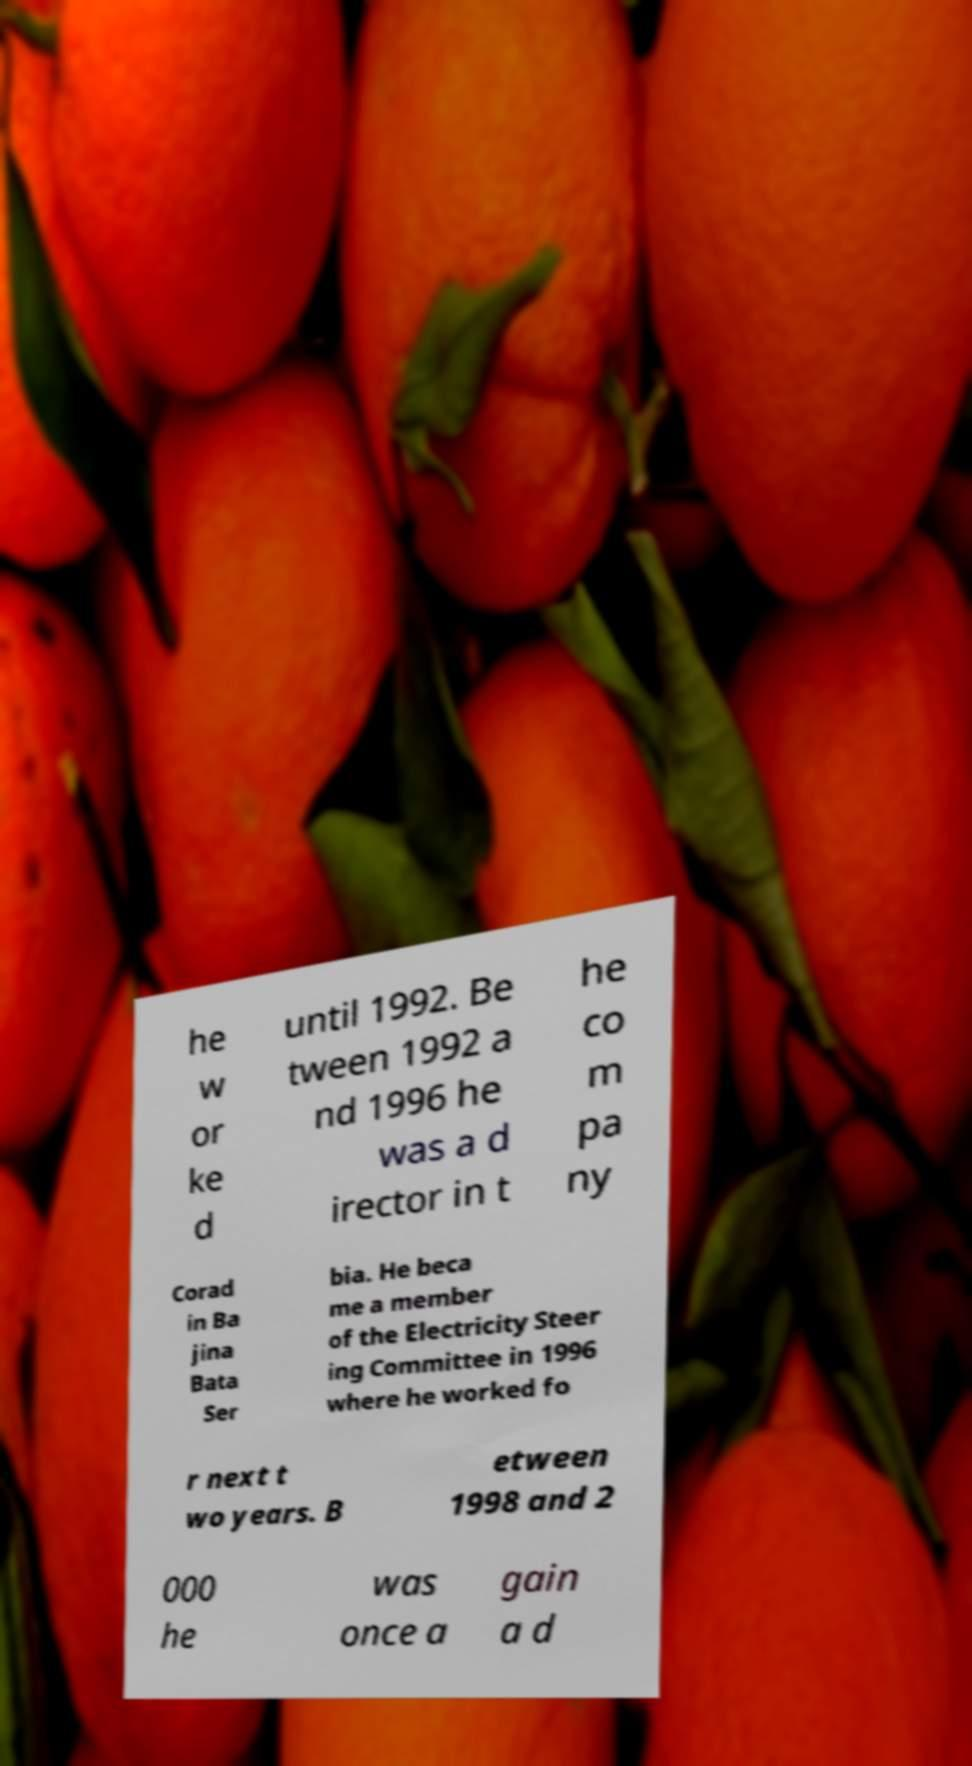Can you read and provide the text displayed in the image?This photo seems to have some interesting text. Can you extract and type it out for me? he w or ke d until 1992. Be tween 1992 a nd 1996 he was a d irector in t he co m pa ny Corad in Ba jina Bata Ser bia. He beca me a member of the Electricity Steer ing Committee in 1996 where he worked fo r next t wo years. B etween 1998 and 2 000 he was once a gain a d 